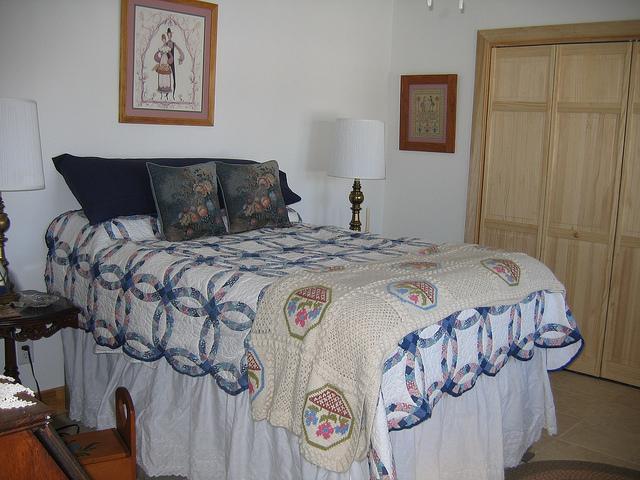How many lamps do you see?
Give a very brief answer. 2. How many pillows do you see?
Give a very brief answer. 3. How many train cars are there in this scene?
Give a very brief answer. 0. 